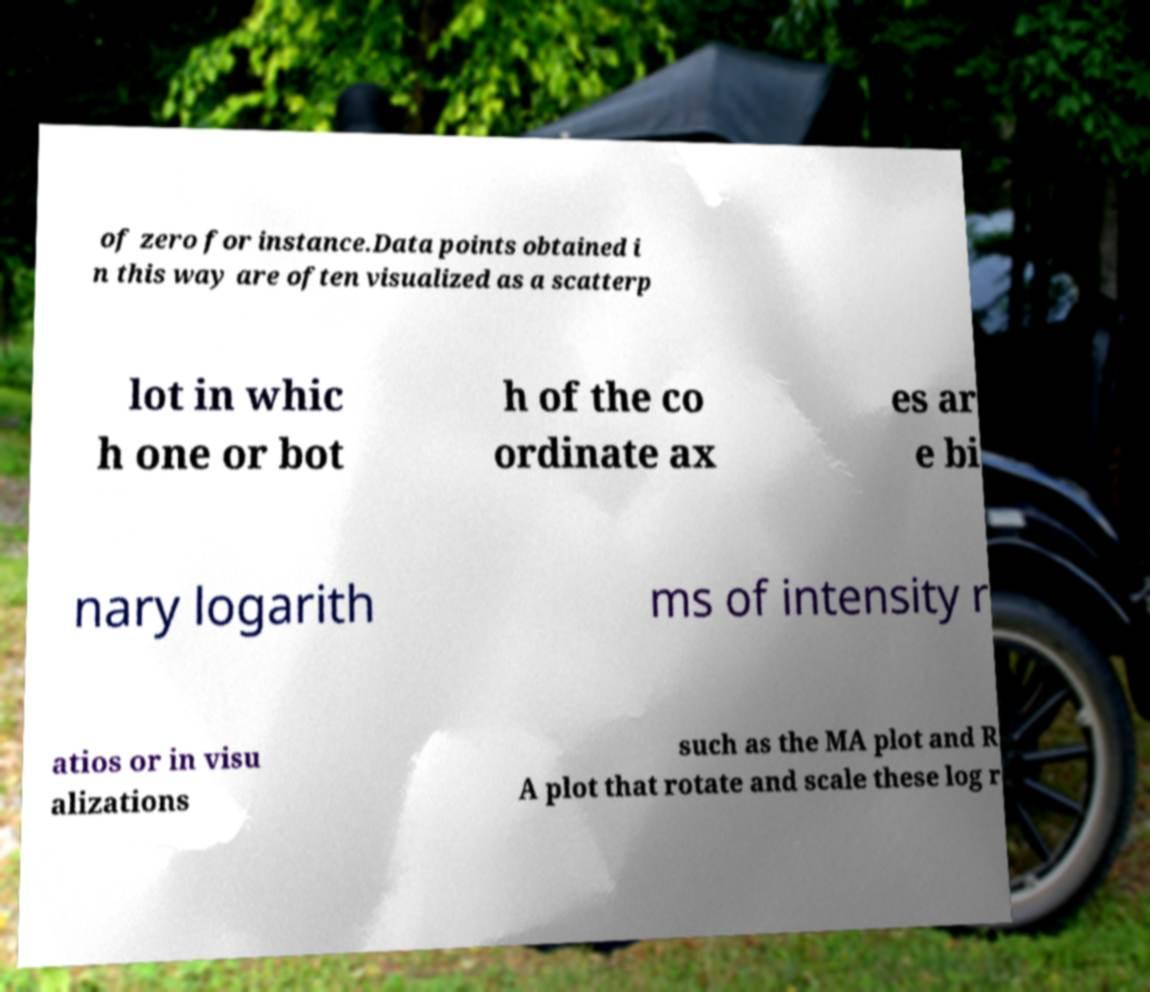What messages or text are displayed in this image? I need them in a readable, typed format. of zero for instance.Data points obtained i n this way are often visualized as a scatterp lot in whic h one or bot h of the co ordinate ax es ar e bi nary logarith ms of intensity r atios or in visu alizations such as the MA plot and R A plot that rotate and scale these log r 